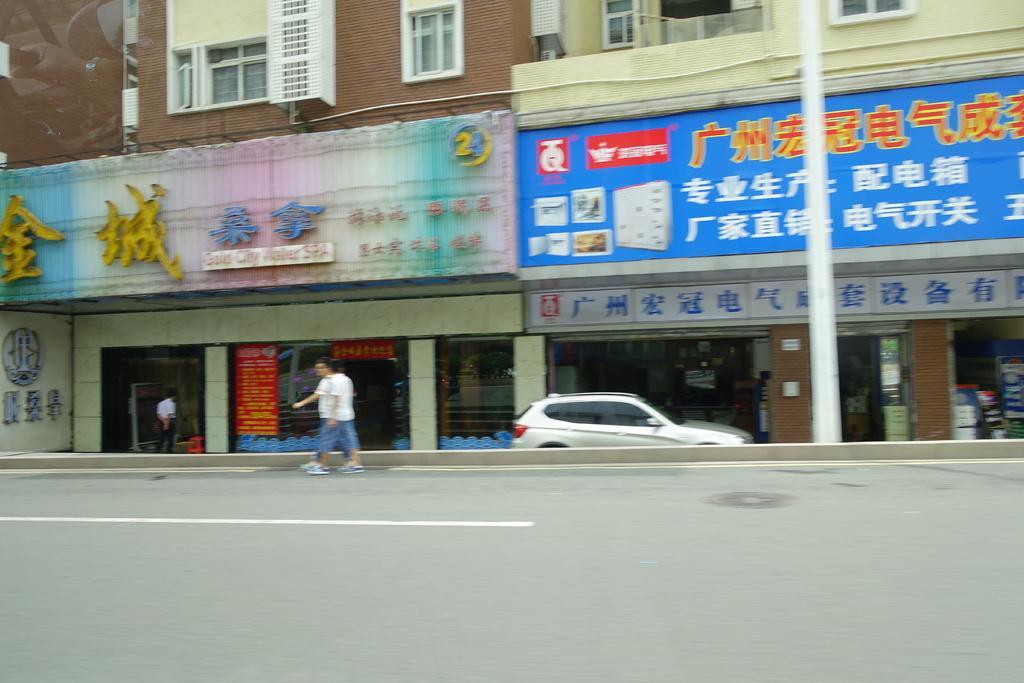Please provide a concise description of this image. In this image, there are two persons wearing clothes and walking on the road which is beside the building. There is a car in the middle of the image. There is pole on the right side of the image. 